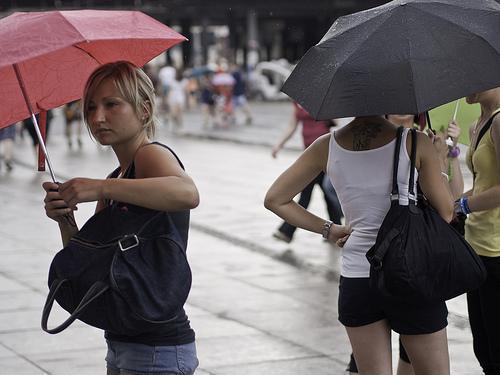How many red umbrellas are shown?
Give a very brief answer. 1. 